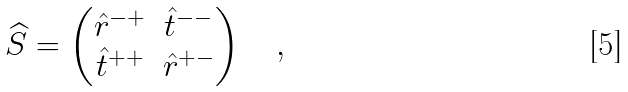<formula> <loc_0><loc_0><loc_500><loc_500>\widehat { S } = \begin{pmatrix} \hat { r } ^ { - + } & \hat { t } ^ { - - } \\ \hat { t } ^ { + + } & \hat { r } ^ { + - } \end{pmatrix} \quad ,</formula> 